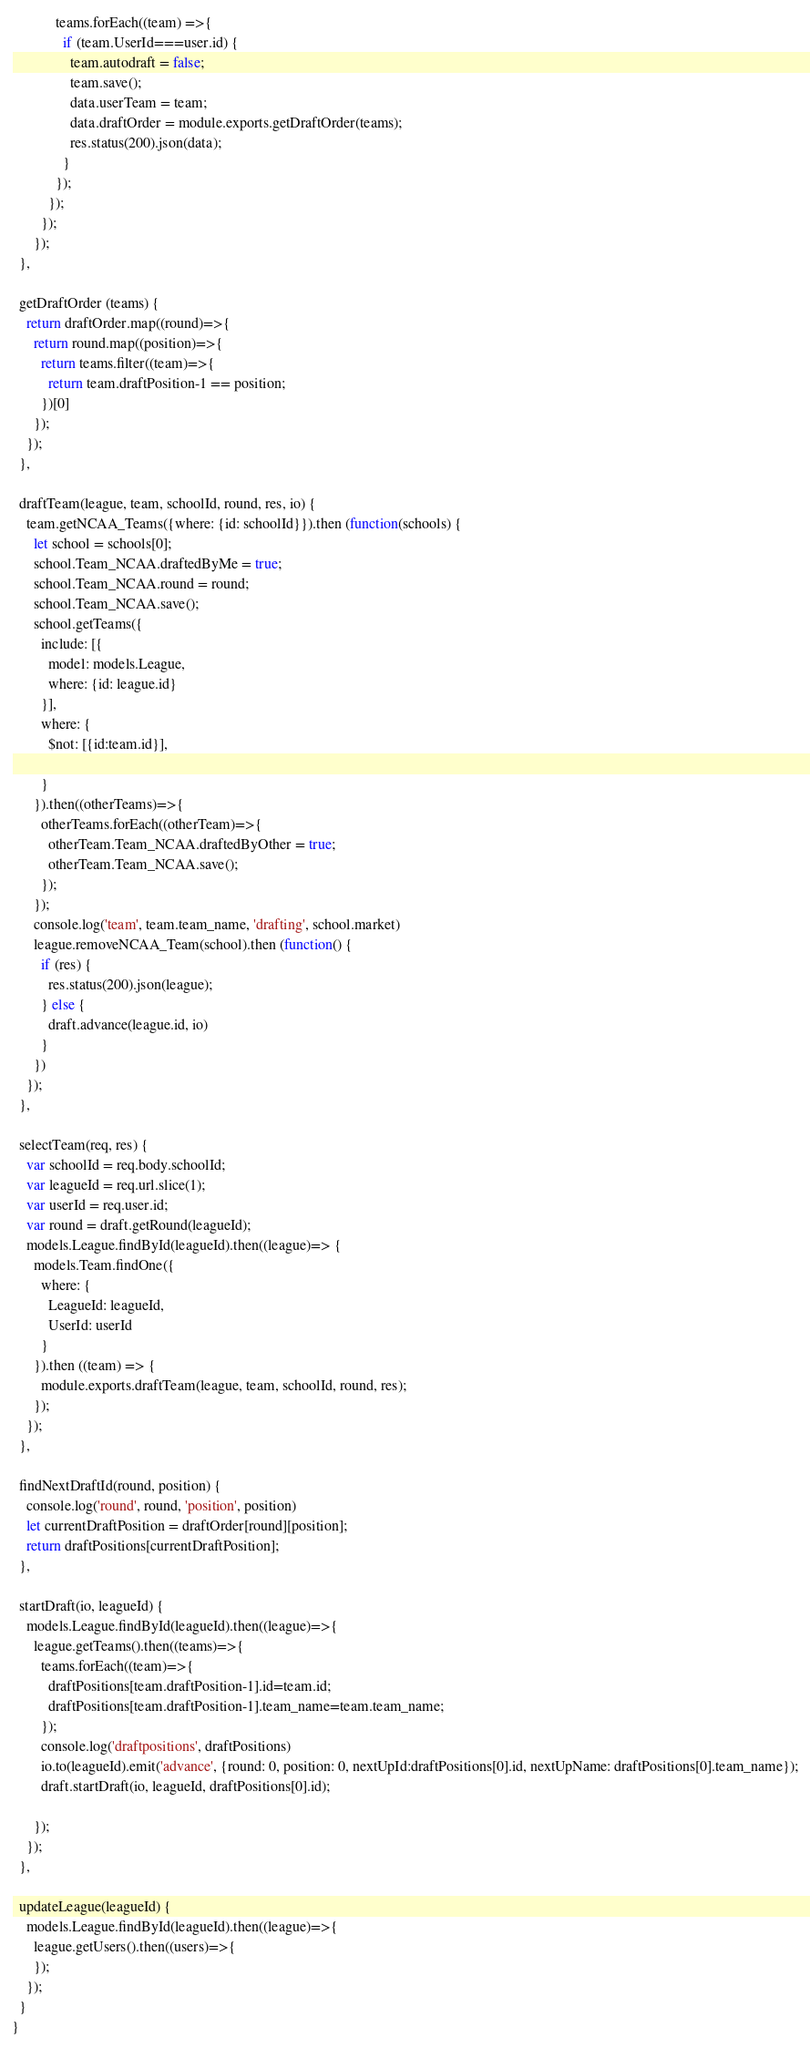Convert code to text. <code><loc_0><loc_0><loc_500><loc_500><_JavaScript_>            teams.forEach((team) =>{
              if (team.UserId===user.id) {
                team.autodraft = false;
                team.save();
                data.userTeam = team;
                data.draftOrder = module.exports.getDraftOrder(teams);
                res.status(200).json(data);
              }
            });
          });
        });
      });
  },

  getDraftOrder (teams) {
    return draftOrder.map((round)=>{
      return round.map((position)=>{
        return teams.filter((team)=>{
          return team.draftPosition-1 == position;
        })[0]
      });
    });
  },

  draftTeam(league, team, schoolId, round, res, io) {
    team.getNCAA_Teams({where: {id: schoolId}}).then (function(schools) {
      let school = schools[0];
      school.Team_NCAA.draftedByMe = true;
      school.Team_NCAA.round = round;
      school.Team_NCAA.save();
      school.getTeams({
        include: [{
          model: models.League,
          where: {id: league.id}
        }],
        where: {
          $not: [{id:team.id}],

        }
      }).then((otherTeams)=>{
        otherTeams.forEach((otherTeam)=>{
          otherTeam.Team_NCAA.draftedByOther = true;
          otherTeam.Team_NCAA.save();
        });
      });
      console.log('team', team.team_name, 'drafting', school.market)
      league.removeNCAA_Team(school).then (function() {
        if (res) {
          res.status(200).json(league);
        } else {
          draft.advance(league.id, io)
        }
      })
    });
  },

  selectTeam(req, res) {
    var schoolId = req.body.schoolId;
    var leagueId = req.url.slice(1);
    var userId = req.user.id;
    var round = draft.getRound(leagueId);
    models.League.findById(leagueId).then((league)=> {
      models.Team.findOne({
        where: {
          LeagueId: leagueId,
          UserId: userId
        }
      }).then ((team) => {
        module.exports.draftTeam(league, team, schoolId, round, res);
      });
    });
  },

  findNextDraftId(round, position) {
    console.log('round', round, 'position', position)
    let currentDraftPosition = draftOrder[round][position];
    return draftPositions[currentDraftPosition];
  },

  startDraft(io, leagueId) {
    models.League.findById(leagueId).then((league)=>{
      league.getTeams().then((teams)=>{
        teams.forEach((team)=>{
          draftPositions[team.draftPosition-1].id=team.id;
          draftPositions[team.draftPosition-1].team_name=team.team_name;
        });
        console.log('draftpositions', draftPositions)
        io.to(leagueId).emit('advance', {round: 0, position: 0, nextUpId:draftPositions[0].id, nextUpName: draftPositions[0].team_name});
        draft.startDraft(io, leagueId, draftPositions[0].id);

      });
    });
  },

  updateLeague(leagueId) {
    models.League.findById(leagueId).then((league)=>{
      league.getUsers().then((users)=>{
      });
    });
  }
}
</code> 